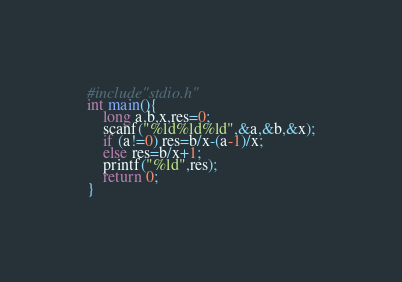Convert code to text. <code><loc_0><loc_0><loc_500><loc_500><_C_>#include"stdio.h"
int main(){
    long a,b,x,res=0;
    scanf("%ld%ld%ld",&a,&b,&x);
    if (a!=0) res=b/x-(a-1)/x;
    else res=b/x+1;
    printf("%ld",res);
    return 0;
}</code> 